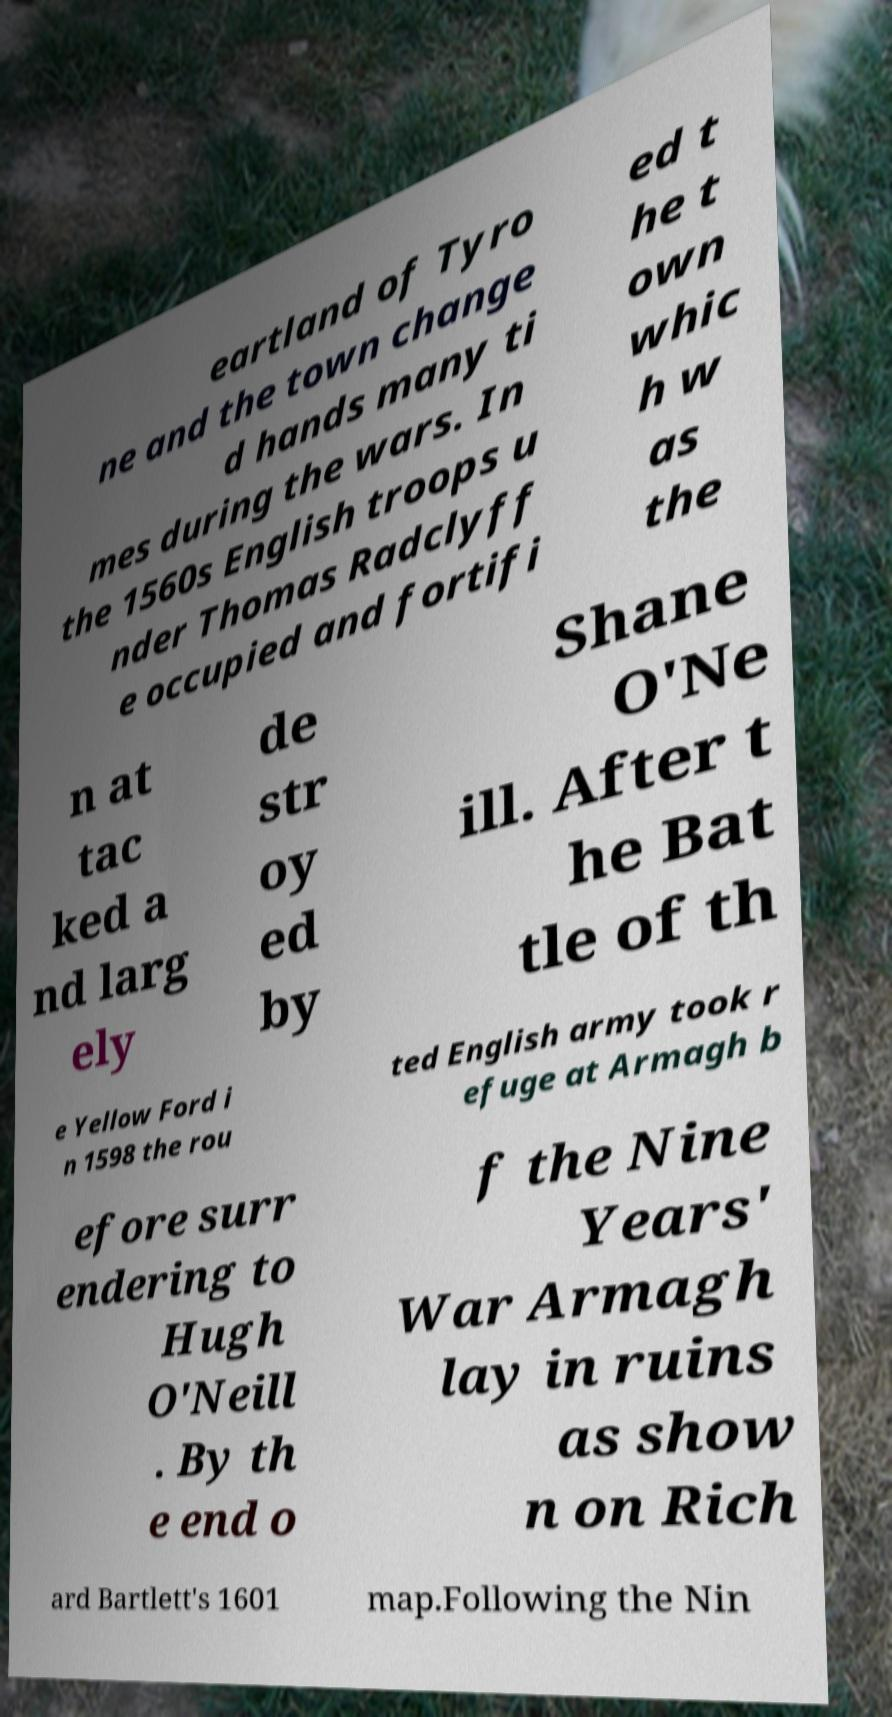Could you extract and type out the text from this image? eartland of Tyro ne and the town change d hands many ti mes during the wars. In the 1560s English troops u nder Thomas Radclyff e occupied and fortifi ed t he t own whic h w as the n at tac ked a nd larg ely de str oy ed by Shane O'Ne ill. After t he Bat tle of th e Yellow Ford i n 1598 the rou ted English army took r efuge at Armagh b efore surr endering to Hugh O'Neill . By th e end o f the Nine Years' War Armagh lay in ruins as show n on Rich ard Bartlett's 1601 map.Following the Nin 